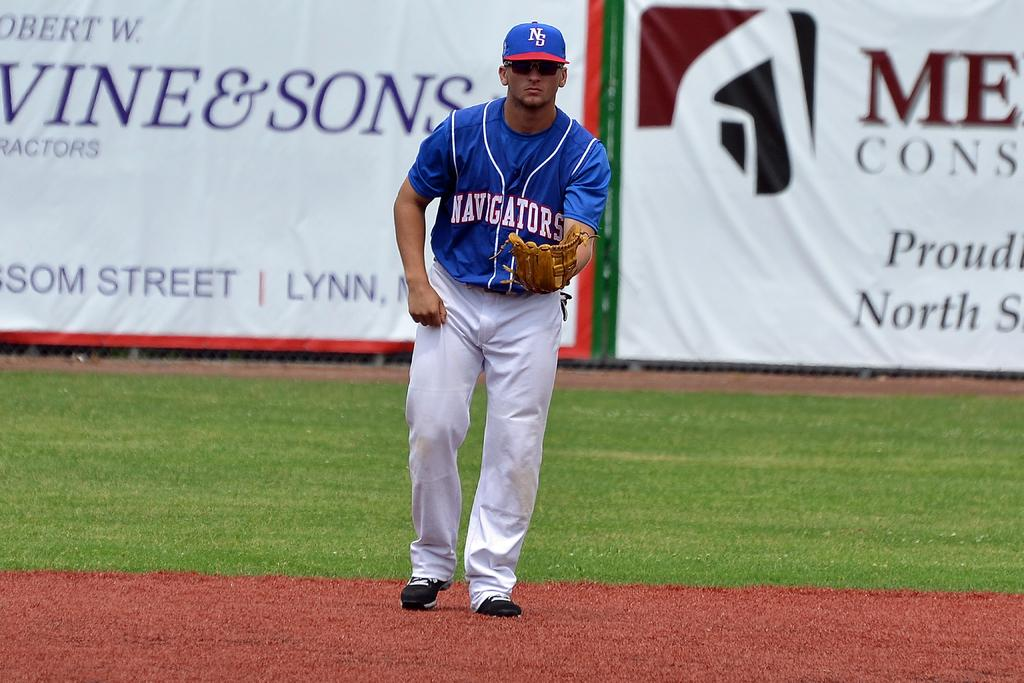<image>
Render a clear and concise summary of the photo. A player for the Navigators is on the baseball field. 